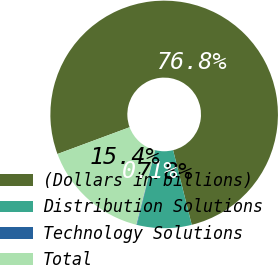Convert chart. <chart><loc_0><loc_0><loc_500><loc_500><pie_chart><fcel>(Dollars in billions)<fcel>Distribution Solutions<fcel>Technology Solutions<fcel>Total<nl><fcel>76.76%<fcel>7.75%<fcel>0.08%<fcel>15.41%<nl></chart> 